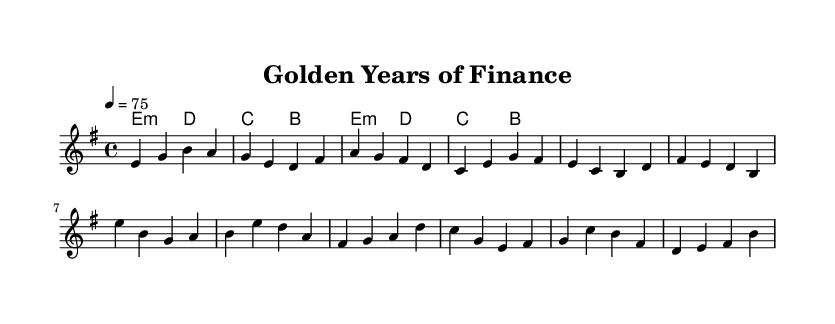What is the key signature of this music? The key signature is indicated by the presence of one sharp note, which is F#. This corresponds to E minor, where F# is the raised seventh scale degree.
Answer: E minor What is the time signature of this music? The time signature is shown at the beginning of the sheet music, indicated by the fraction 4/4, which means there are four beats in each measure and a quarter note receives one beat.
Answer: 4/4 What is the tempo marking of this piece? The tempo marking is found at the beginning of the sheet music, written as "4 = 75," indicating that the quarter note should be played at a speed of 75 beats per minute.
Answer: 75 How many measures are in the verse? The verse section is composed of 4 measures, as counted by the groupings of notes before the chorus starts.
Answer: 4 What is the main theme expressed in the chorus? The chorus reflects on a lifetime of service with fond memories of a career in finance, as indicated by the lyrics provided alongside the melody.
Answer: A lifetime of service Which musical structure is predominantly used in this piece? The piece follows a traditional verse-chorus structure, where the verse introduces the themes and the chorus reiterates the main ideas, typical in ballads, including power metal ballads.
Answer: Verse-chorus 